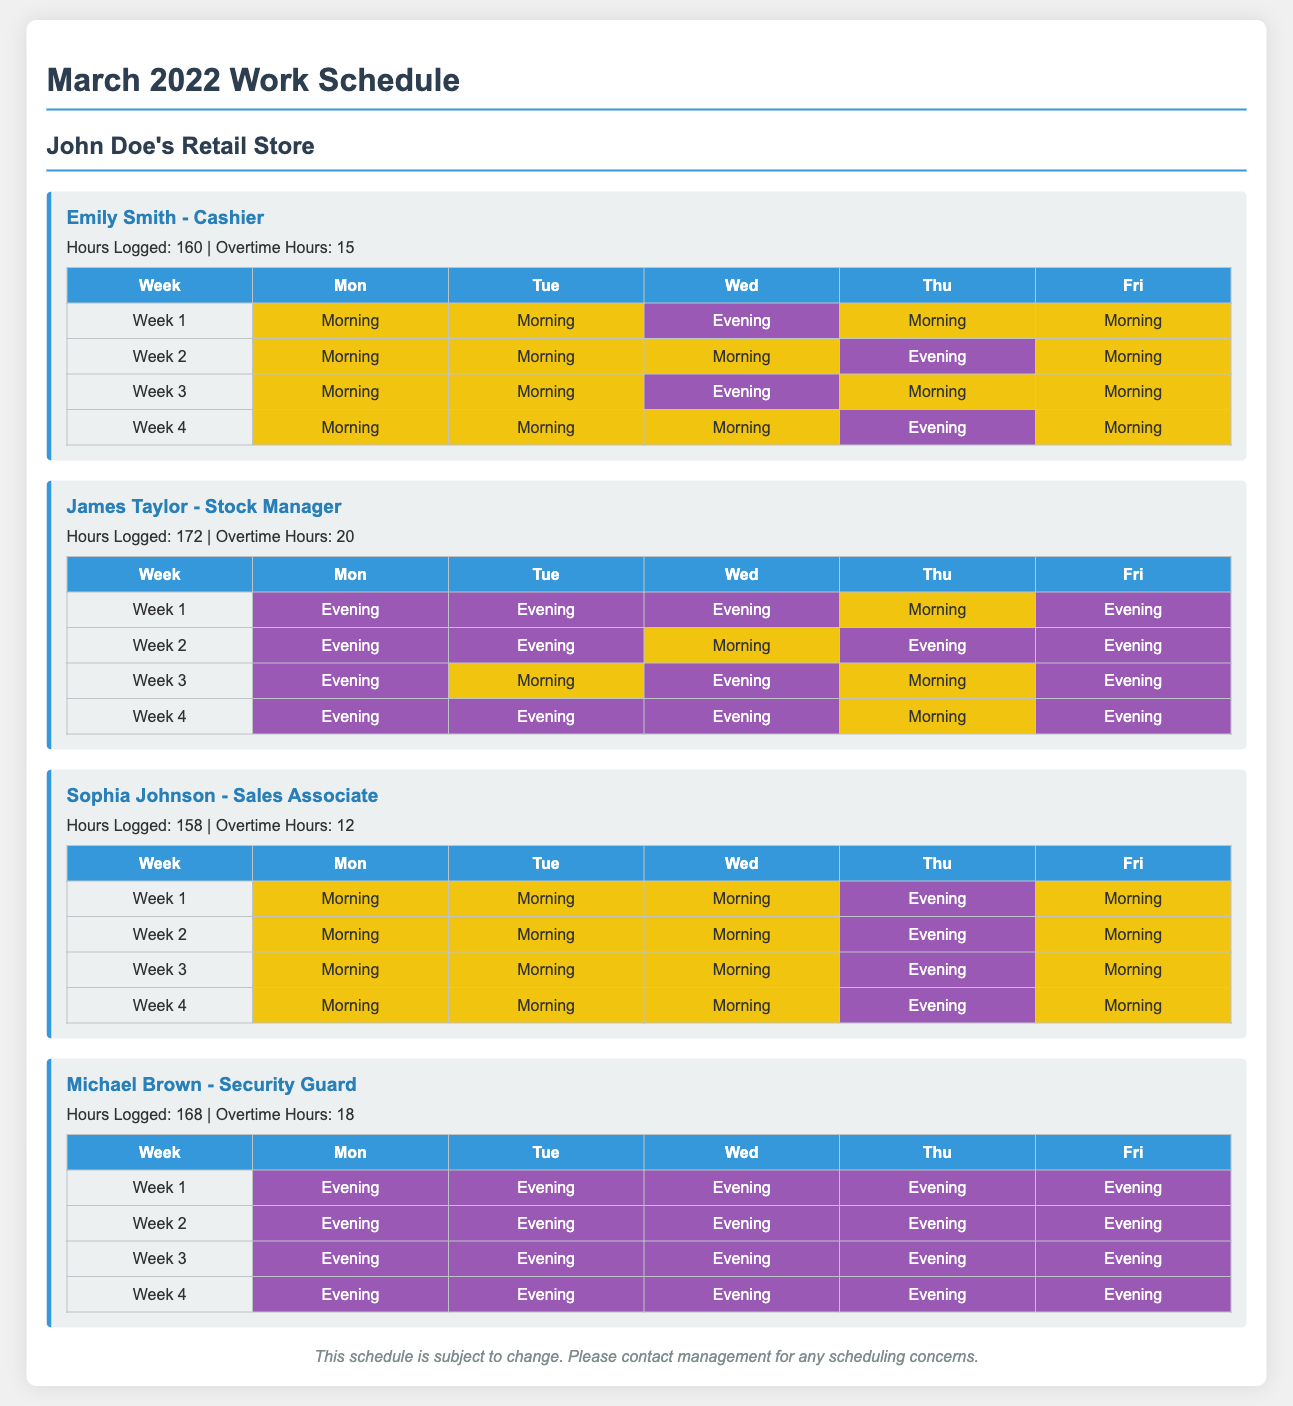what is the total hours logged by Emily Smith? Emily Smith logged 160 hours in March 2022 as indicated in her employee details.
Answer: 160 how many overtime hours did James Taylor work? James Taylor worked 20 overtime hours as mentioned in his employee details.
Answer: 20 what shift did Sophia Johnson have on Thursday of Week 1? On Thursday of Week 1, Sophia Johnson worked the evening shift, as indicated in the shift table.
Answer: Evening who is the Security Guard in the schedule? The Security Guard's name is Michael Brown, stated at the beginning of his employee card.
Answer: Michael Brown how many total employees are listed in the document? The document lists four employees, each with their own employee card.
Answer: 4 which employee worked the most overtime? James Taylor worked the most overtime hours at 20, as noted in his details.
Answer: James Taylor what shift type is displayed for all of Michael Brown's shifts? All of Michael Brown's shifts are evening shifts, as shown in his shift table.
Answer: Evening what is the maximum number of hours logged by any employee? The maximum hours logged is 172 by James Taylor, found in his employee details.
Answer: 172 how many weeks are represented in Emily Smith's shift schedule? Emily Smith's shift schedule contains four weeks, represented in the shift table.
Answer: 4 